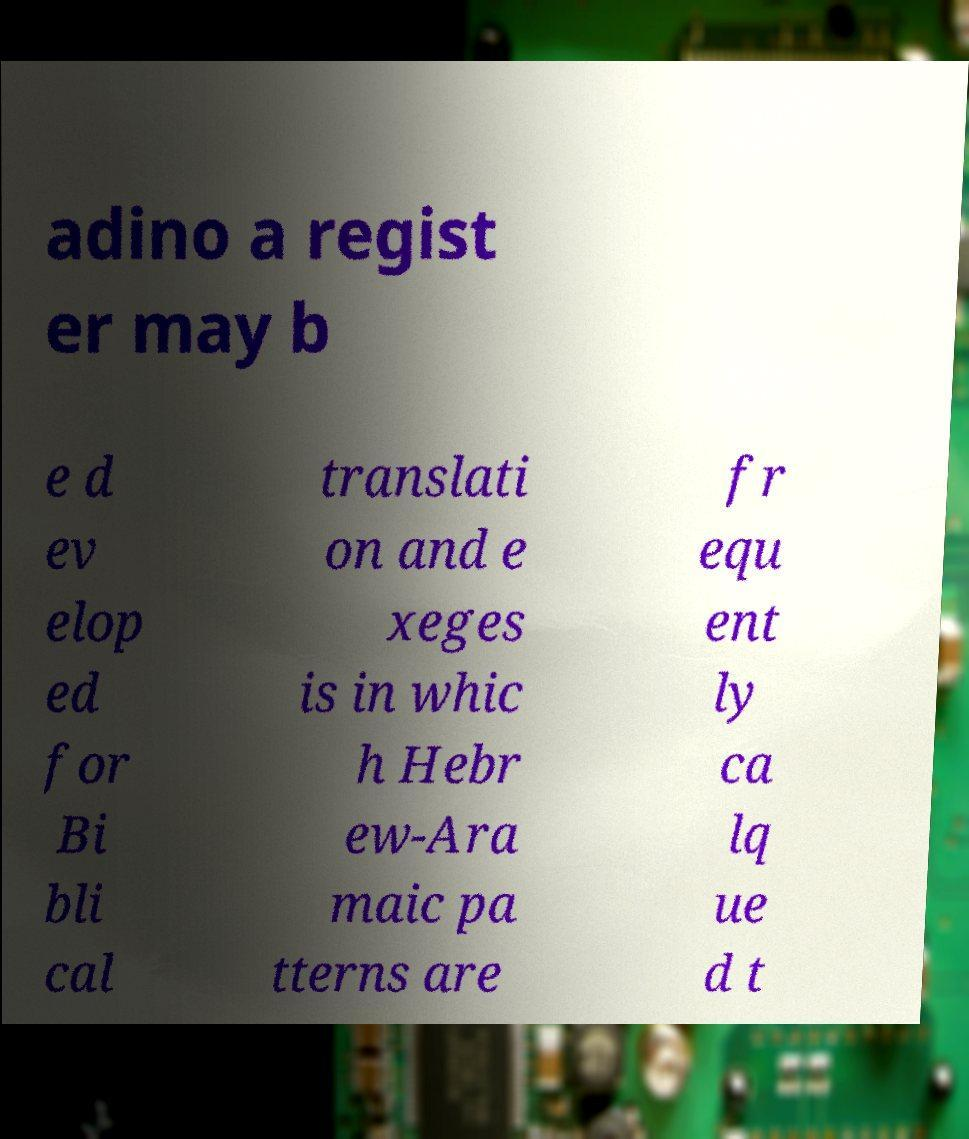Can you accurately transcribe the text from the provided image for me? adino a regist er may b e d ev elop ed for Bi bli cal translati on and e xeges is in whic h Hebr ew-Ara maic pa tterns are fr equ ent ly ca lq ue d t 